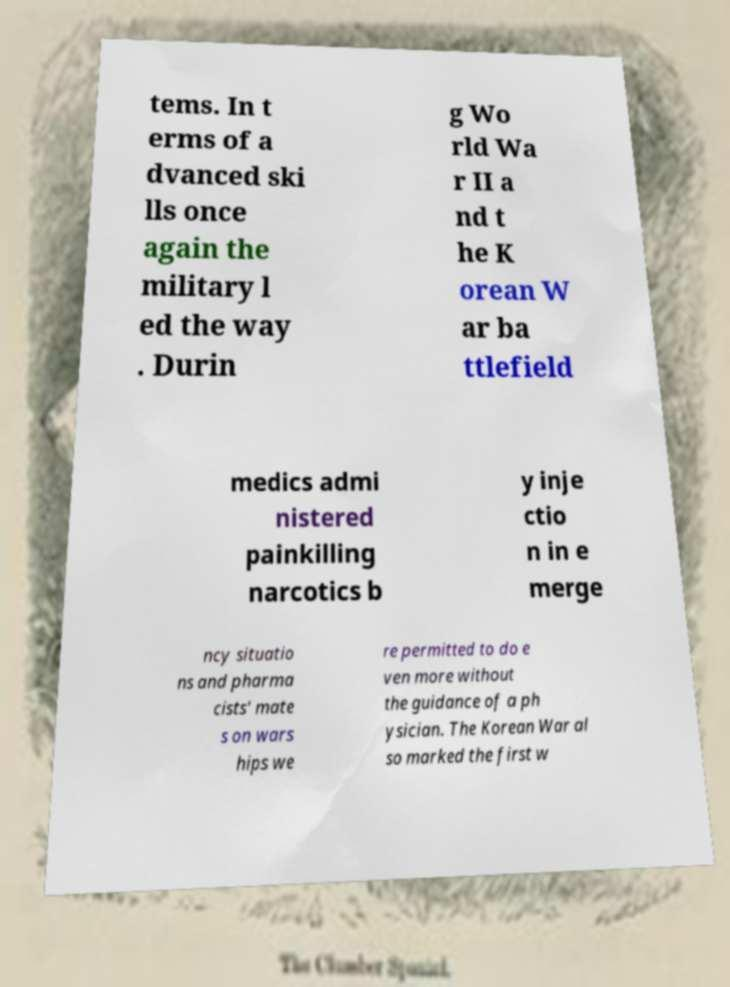I need the written content from this picture converted into text. Can you do that? tems. In t erms of a dvanced ski lls once again the military l ed the way . Durin g Wo rld Wa r II a nd t he K orean W ar ba ttlefield medics admi nistered painkilling narcotics b y inje ctio n in e merge ncy situatio ns and pharma cists' mate s on wars hips we re permitted to do e ven more without the guidance of a ph ysician. The Korean War al so marked the first w 